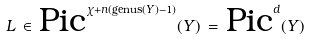<formula> <loc_0><loc_0><loc_500><loc_500>L \, \in \, \text {Pic} ^ { \chi + n ( \text {genus} ( Y ) - 1 ) } ( Y ) \, = \, \text {Pic} ^ { d } ( Y )</formula> 